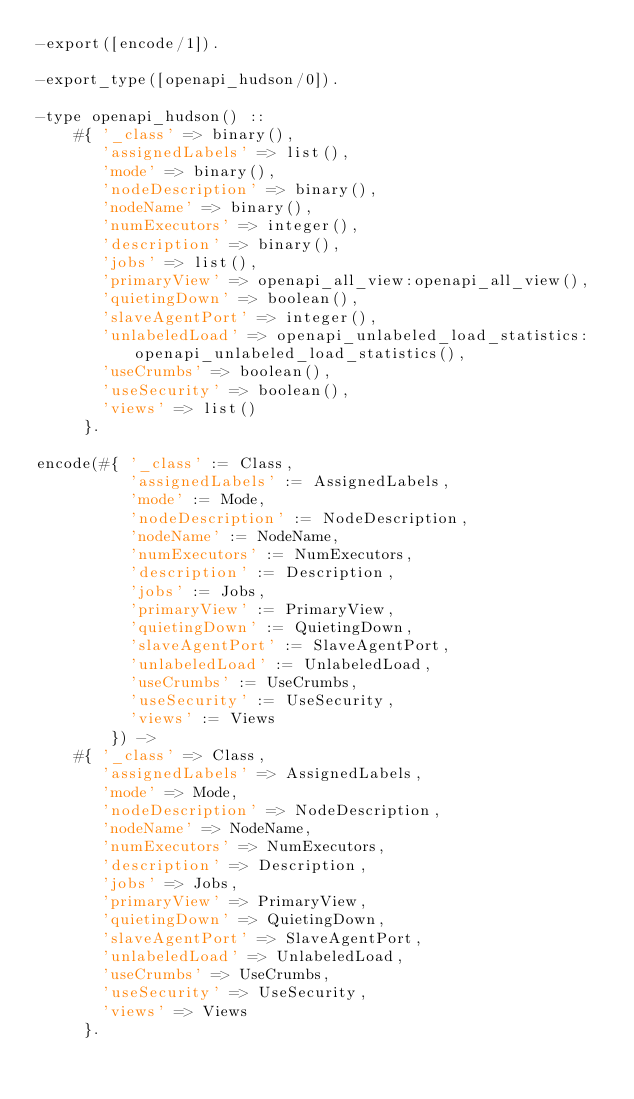Convert code to text. <code><loc_0><loc_0><loc_500><loc_500><_Erlang_>-export([encode/1]).

-export_type([openapi_hudson/0]).

-type openapi_hudson() ::
    #{ '_class' => binary(),
       'assignedLabels' => list(),
       'mode' => binary(),
       'nodeDescription' => binary(),
       'nodeName' => binary(),
       'numExecutors' => integer(),
       'description' => binary(),
       'jobs' => list(),
       'primaryView' => openapi_all_view:openapi_all_view(),
       'quietingDown' => boolean(),
       'slaveAgentPort' => integer(),
       'unlabeledLoad' => openapi_unlabeled_load_statistics:openapi_unlabeled_load_statistics(),
       'useCrumbs' => boolean(),
       'useSecurity' => boolean(),
       'views' => list()
     }.

encode(#{ '_class' := Class,
          'assignedLabels' := AssignedLabels,
          'mode' := Mode,
          'nodeDescription' := NodeDescription,
          'nodeName' := NodeName,
          'numExecutors' := NumExecutors,
          'description' := Description,
          'jobs' := Jobs,
          'primaryView' := PrimaryView,
          'quietingDown' := QuietingDown,
          'slaveAgentPort' := SlaveAgentPort,
          'unlabeledLoad' := UnlabeledLoad,
          'useCrumbs' := UseCrumbs,
          'useSecurity' := UseSecurity,
          'views' := Views
        }) ->
    #{ '_class' => Class,
       'assignedLabels' => AssignedLabels,
       'mode' => Mode,
       'nodeDescription' => NodeDescription,
       'nodeName' => NodeName,
       'numExecutors' => NumExecutors,
       'description' => Description,
       'jobs' => Jobs,
       'primaryView' => PrimaryView,
       'quietingDown' => QuietingDown,
       'slaveAgentPort' => SlaveAgentPort,
       'unlabeledLoad' => UnlabeledLoad,
       'useCrumbs' => UseCrumbs,
       'useSecurity' => UseSecurity,
       'views' => Views
     }.
</code> 